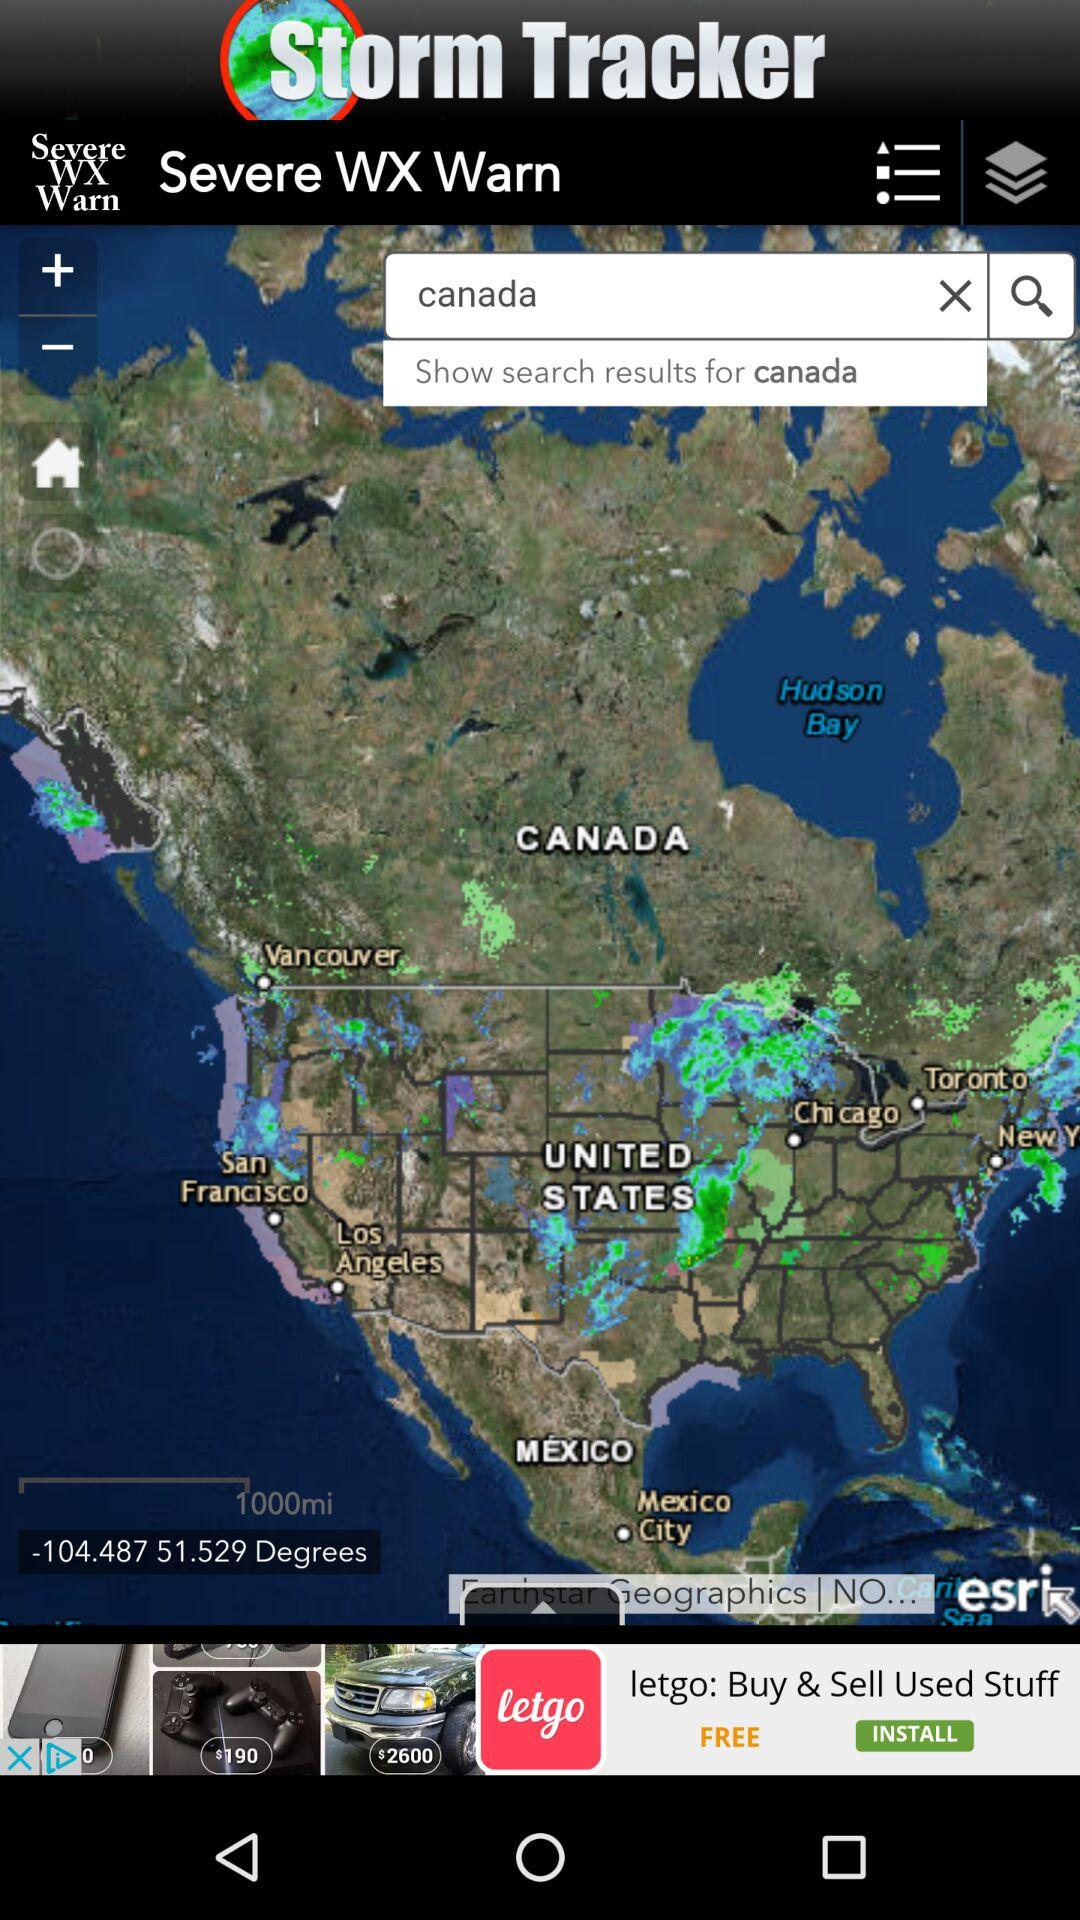What location is being searched? The location that is being searched is Canada. 